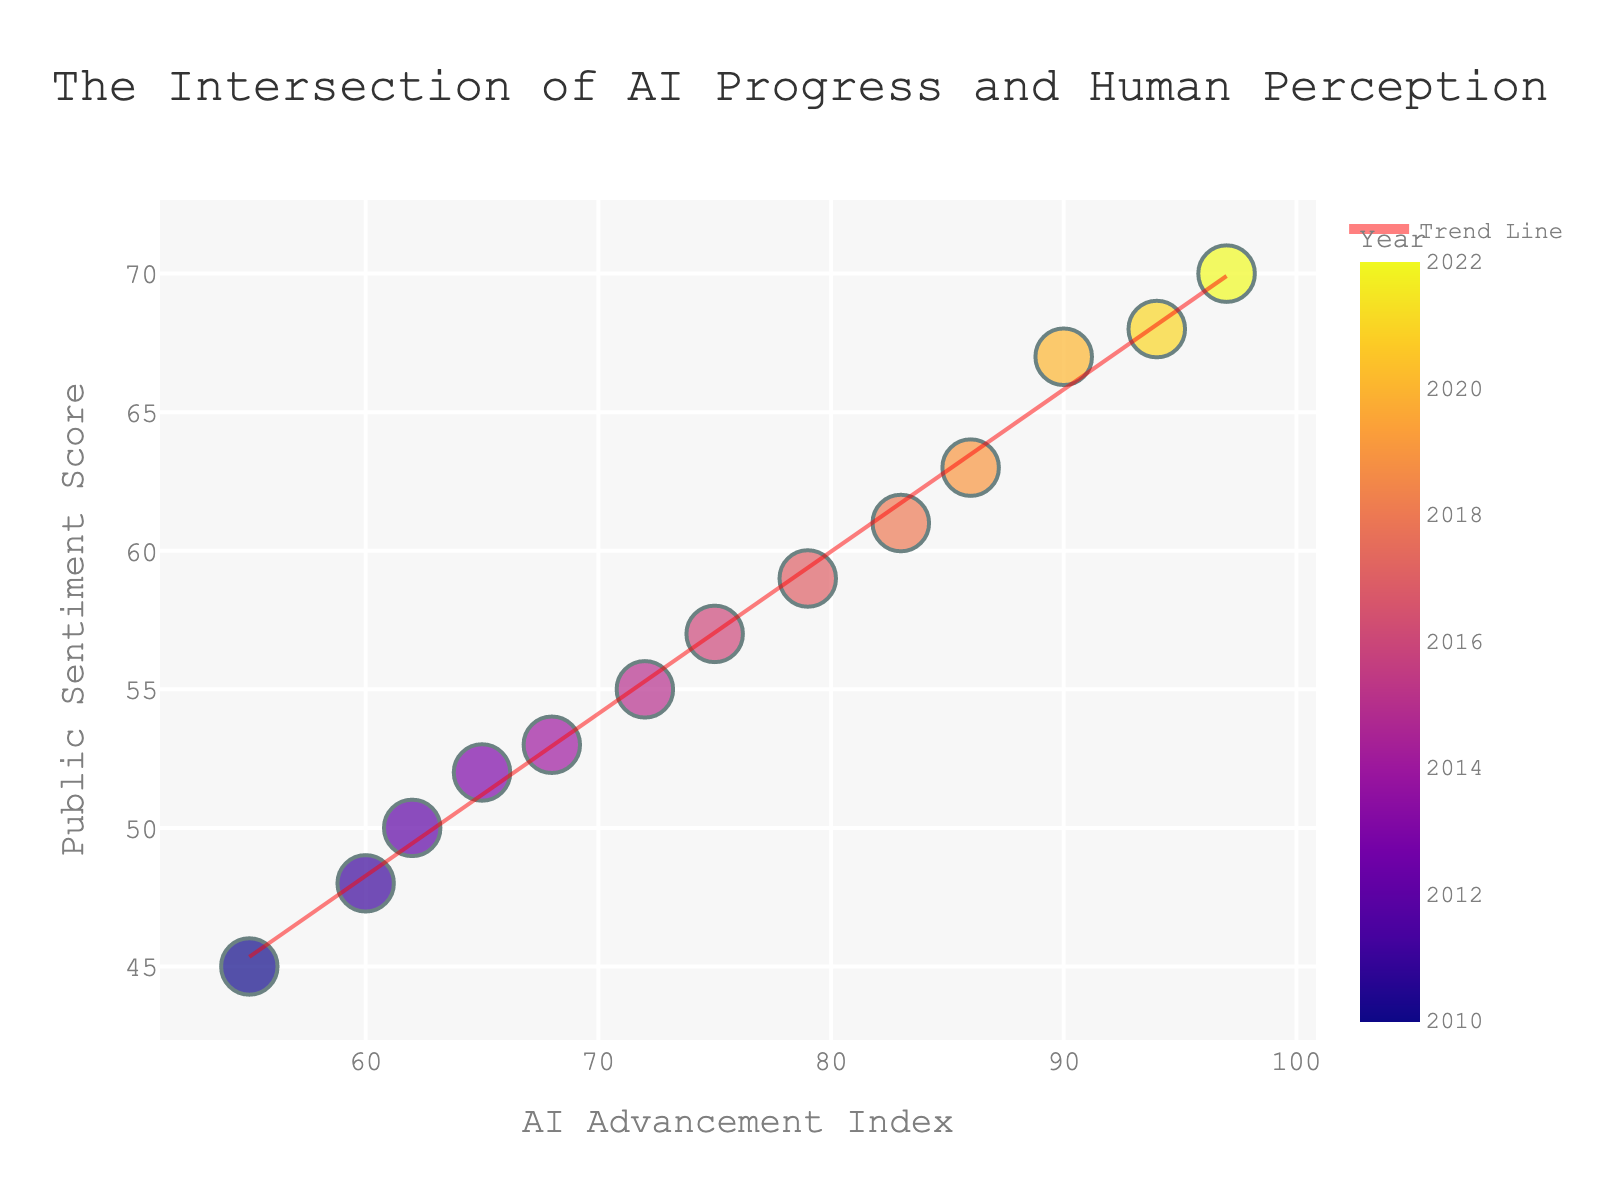What is the title of the plot? The title is prominently displayed at the top of the plot. It reads "The Intersection of AI Progress and Human Perception"
Answer: The Intersection of AI Progress and Human Perception What is the color of the trend line in the plot? The trend line is clearly visible in the plot and is colored in a translucent red
Answer: Translucent red What are the axis titles of the plot? The x-axis title is "AI Advancement Index" and the y-axis title is "Public Sentiment Score"
Answer: AI Advancement Index and Public Sentiment Score How many data points are displayed in the plot? By counting the individual markers in the scatter plot, you can see that there are 13 data points
Answer: 13 What do the sizes of the markers represent in the plot? The size of the markers corresponds to the "Year" variable, which is indicated in the plot’s hover data
Answer: Year What is the general trend of public sentiment with respect to AI advancements? The trend line shows a positive slope, indicating that as the AI Advancement Index increases, the Public Sentiment Score also increases
Answer: As AI advances, public sentiment improves Between which years does the data in the plot range? By examining the hover data of the points and the progression of the years associated with them, it’s clear that the data ranges from 2010 to 2022
Answer: 2010 to 2022 Which year shows the highest AI Advancement Index and what is its Public Sentiment Score? The year 2022 shows the highest AI Advancement Index, which is 97. Corresponding to this index, the Public Sentiment Score is 70
Answer: 2022, 70 Is there any year where the AI Advancement Index and Public Sentiment Score are both less than 60? By looking at the marker values, you can see that both the AI Advancement Index (55) and the Public Sentiment Score (45) are less than 60 in 2010
Answer: 2010 How does the AI Advancement Index in 2015 compare to that in 2018? The AI Advancement Index in 2015 is 72, and in 2018, it is 83, indicating that the index increased from 2015 to 2018
Answer: It increased from 2015 to 2018 